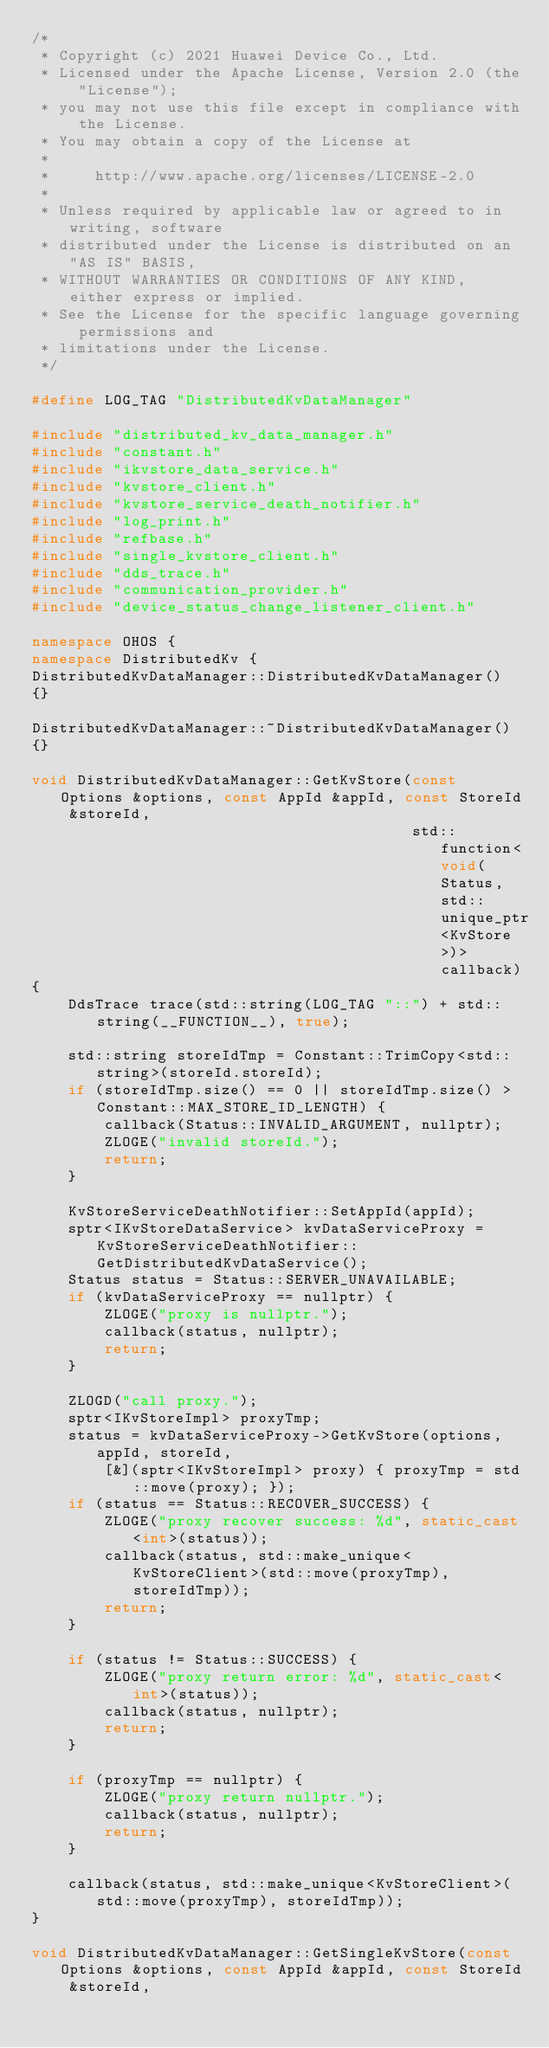Convert code to text. <code><loc_0><loc_0><loc_500><loc_500><_C++_>/*
 * Copyright (c) 2021 Huawei Device Co., Ltd.
 * Licensed under the Apache License, Version 2.0 (the "License");
 * you may not use this file except in compliance with the License.
 * You may obtain a copy of the License at
 *
 *     http://www.apache.org/licenses/LICENSE-2.0
 *
 * Unless required by applicable law or agreed to in writing, software
 * distributed under the License is distributed on an "AS IS" BASIS,
 * WITHOUT WARRANTIES OR CONDITIONS OF ANY KIND, either express or implied.
 * See the License for the specific language governing permissions and
 * limitations under the License.
 */

#define LOG_TAG "DistributedKvDataManager"

#include "distributed_kv_data_manager.h"
#include "constant.h"
#include "ikvstore_data_service.h"
#include "kvstore_client.h"
#include "kvstore_service_death_notifier.h"
#include "log_print.h"
#include "refbase.h"
#include "single_kvstore_client.h"
#include "dds_trace.h"
#include "communication_provider.h"
#include "device_status_change_listener_client.h"

namespace OHOS {
namespace DistributedKv {
DistributedKvDataManager::DistributedKvDataManager()
{}

DistributedKvDataManager::~DistributedKvDataManager()
{}

void DistributedKvDataManager::GetKvStore(const Options &options, const AppId &appId, const StoreId &storeId,
                                          std::function<void(Status, std::unique_ptr<KvStore>)> callback)
{
    DdsTrace trace(std::string(LOG_TAG "::") + std::string(__FUNCTION__), true);

    std::string storeIdTmp = Constant::TrimCopy<std::string>(storeId.storeId);
    if (storeIdTmp.size() == 0 || storeIdTmp.size() > Constant::MAX_STORE_ID_LENGTH) {
        callback(Status::INVALID_ARGUMENT, nullptr);
        ZLOGE("invalid storeId.");
        return;
    }

    KvStoreServiceDeathNotifier::SetAppId(appId);
    sptr<IKvStoreDataService> kvDataServiceProxy = KvStoreServiceDeathNotifier::GetDistributedKvDataService();
    Status status = Status::SERVER_UNAVAILABLE;
    if (kvDataServiceProxy == nullptr) {
        ZLOGE("proxy is nullptr.");
        callback(status, nullptr);
        return;
    }

    ZLOGD("call proxy.");
    sptr<IKvStoreImpl> proxyTmp;
    status = kvDataServiceProxy->GetKvStore(options, appId, storeId,
        [&](sptr<IKvStoreImpl> proxy) { proxyTmp = std::move(proxy); });
    if (status == Status::RECOVER_SUCCESS) {
        ZLOGE("proxy recover success: %d", static_cast<int>(status));
        callback(status, std::make_unique<KvStoreClient>(std::move(proxyTmp), storeIdTmp));
        return;
    }

    if (status != Status::SUCCESS) {
        ZLOGE("proxy return error: %d", static_cast<int>(status));
        callback(status, nullptr);
        return;
    }

    if (proxyTmp == nullptr) {
        ZLOGE("proxy return nullptr.");
        callback(status, nullptr);
        return;
    }

    callback(status, std::make_unique<KvStoreClient>(std::move(proxyTmp), storeIdTmp));
}

void DistributedKvDataManager::GetSingleKvStore(const Options &options, const AppId &appId, const StoreId &storeId,</code> 